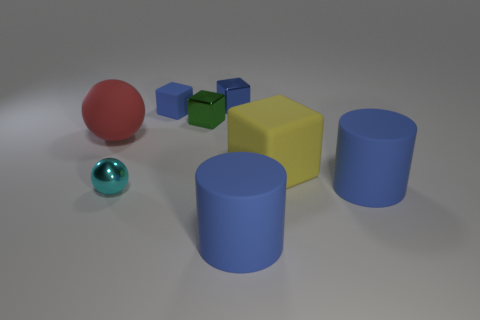Subtract all green blocks. How many blocks are left? 3 Add 1 big cylinders. How many objects exist? 9 Subtract all cyan balls. How many balls are left? 1 Subtract all cylinders. How many objects are left? 6 Add 4 yellow matte cubes. How many yellow matte cubes are left? 5 Add 4 big blocks. How many big blocks exist? 5 Subtract 0 brown blocks. How many objects are left? 8 Subtract 2 balls. How many balls are left? 0 Subtract all purple cubes. Subtract all purple spheres. How many cubes are left? 4 Subtract all blue blocks. How many brown spheres are left? 0 